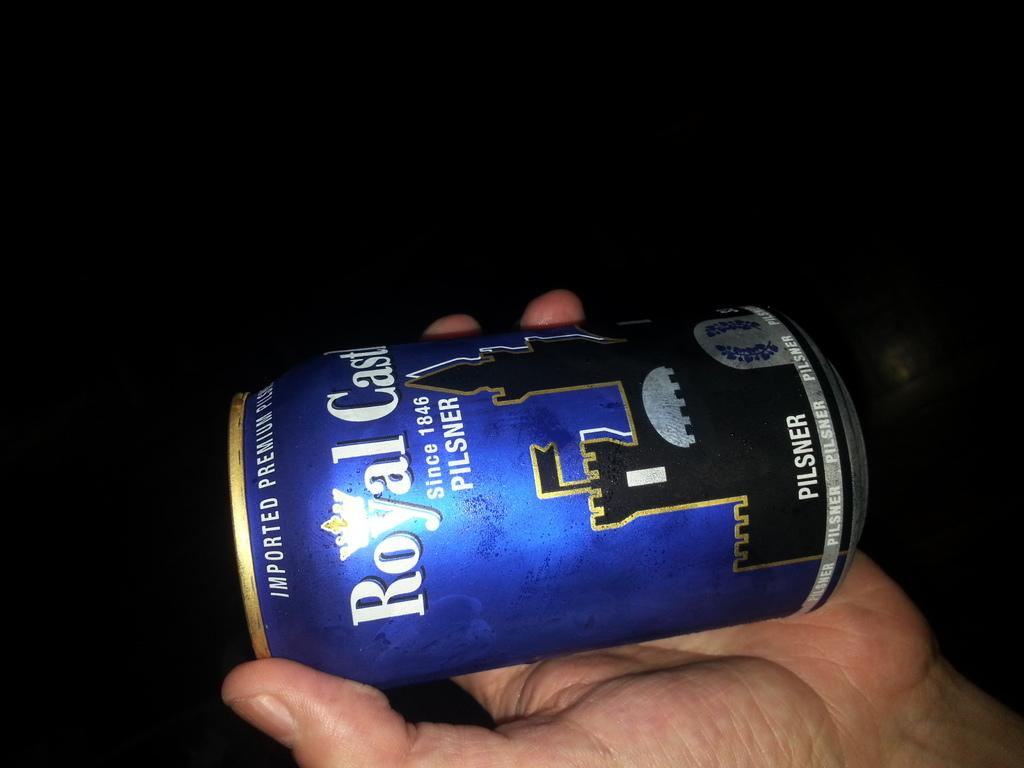<image>
Provide a brief description of the given image. A can of Royal Castle Pilsner beer is being held sideways. 